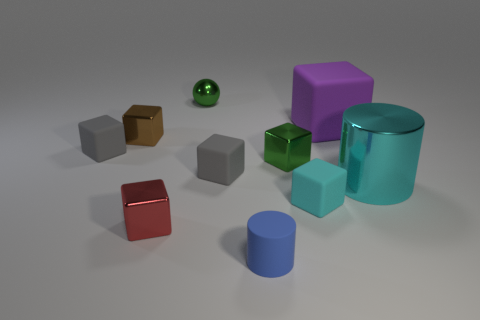There is a blue matte thing that is the same size as the sphere; what shape is it?
Offer a very short reply. Cylinder. Are there any tiny gray rubber things that have the same shape as the blue thing?
Provide a short and direct response. No. Is the cyan cube made of the same material as the cyan thing behind the tiny cyan matte cube?
Provide a succinct answer. No. There is a cylinder that is to the left of the cyan thing left of the big purple matte block; what is its material?
Offer a very short reply. Rubber. Are there more big things that are in front of the green block than tiny purple matte things?
Provide a short and direct response. Yes. Are any cyan matte objects visible?
Make the answer very short. Yes. What color is the tiny thing that is behind the big purple matte object?
Provide a short and direct response. Green. There is a object that is the same size as the purple matte cube; what is its material?
Your answer should be compact. Metal. What number of other things are made of the same material as the brown object?
Your answer should be compact. 4. What is the color of the thing that is behind the small brown shiny object and left of the big purple matte thing?
Make the answer very short. Green. 